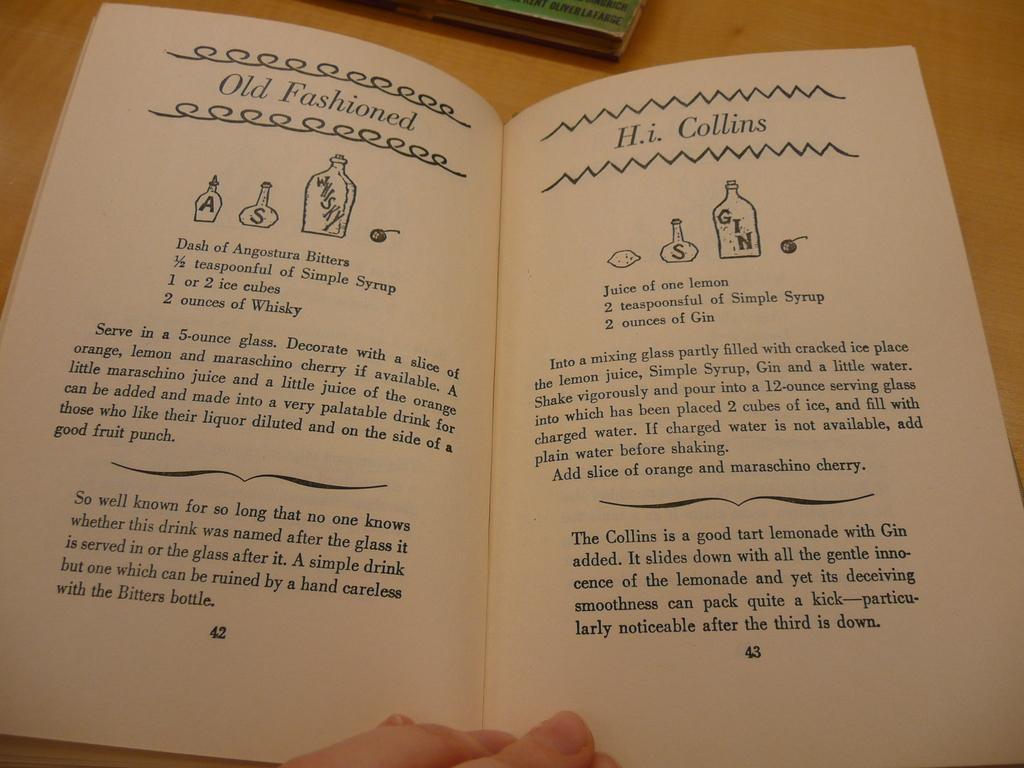<image>
Give a short and clear explanation of the subsequent image. A bartender's manual opened to the pages showing instructions for a an Old Fashioned and an H.i. Collins. 